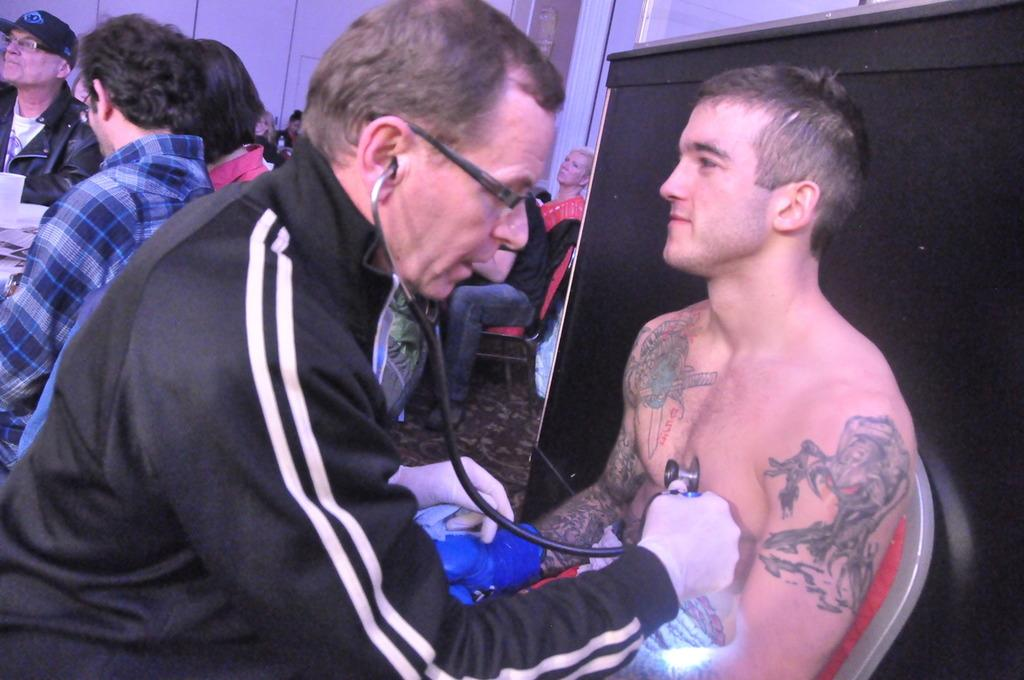How many people are present in the image? There are a few people in the image. What can be seen under the people's feet? The ground is visible in the image. What is on the left side of the image? There are posters on the left side of the image. What is the color of the object on the right side of the image? There is a black colored object on the right side of the image. What is the background of the image made up of? There is a wall in the image. What is the name of the daughter in the image? There is no mention of a daughter in the image, as the facts provided do not include any information about family relationships. 